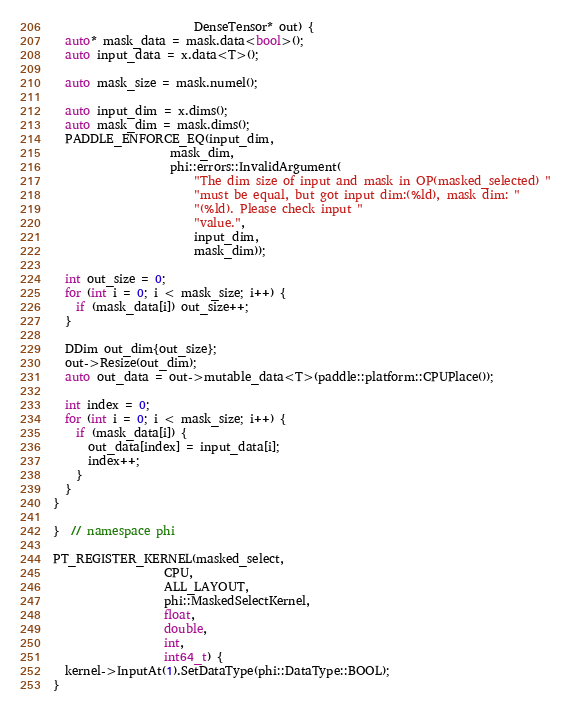Convert code to text. <code><loc_0><loc_0><loc_500><loc_500><_C++_>                        DenseTensor* out) {
  auto* mask_data = mask.data<bool>();
  auto input_data = x.data<T>();

  auto mask_size = mask.numel();

  auto input_dim = x.dims();
  auto mask_dim = mask.dims();
  PADDLE_ENFORCE_EQ(input_dim,
                    mask_dim,
                    phi::errors::InvalidArgument(
                        "The dim size of input and mask in OP(masked_selected) "
                        "must be equal, but got input dim:(%ld), mask dim: "
                        "(%ld). Please check input "
                        "value.",
                        input_dim,
                        mask_dim));

  int out_size = 0;
  for (int i = 0; i < mask_size; i++) {
    if (mask_data[i]) out_size++;
  }

  DDim out_dim{out_size};
  out->Resize(out_dim);
  auto out_data = out->mutable_data<T>(paddle::platform::CPUPlace());

  int index = 0;
  for (int i = 0; i < mask_size; i++) {
    if (mask_data[i]) {
      out_data[index] = input_data[i];
      index++;
    }
  }
}

}  // namespace phi

PT_REGISTER_KERNEL(masked_select,
                   CPU,
                   ALL_LAYOUT,
                   phi::MaskedSelectKernel,
                   float,
                   double,
                   int,
                   int64_t) {
  kernel->InputAt(1).SetDataType(phi::DataType::BOOL);
}
</code> 